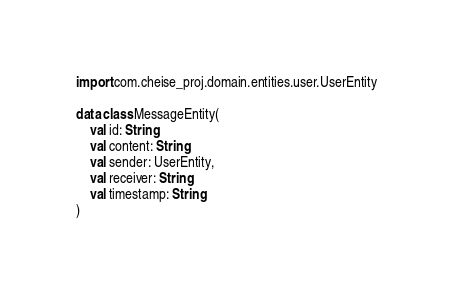<code> <loc_0><loc_0><loc_500><loc_500><_Kotlin_>
import com.cheise_proj.domain.entities.user.UserEntity

data class MessageEntity(
    val id: String,
    val content: String,
    val sender: UserEntity,
    val receiver: String,
    val timestamp: String
)</code> 